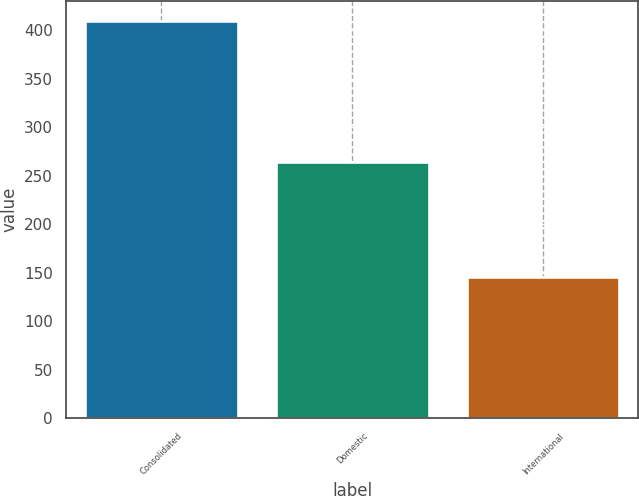<chart> <loc_0><loc_0><loc_500><loc_500><bar_chart><fcel>Consolidated<fcel>Domestic<fcel>International<nl><fcel>409.6<fcel>264.4<fcel>145.2<nl></chart> 